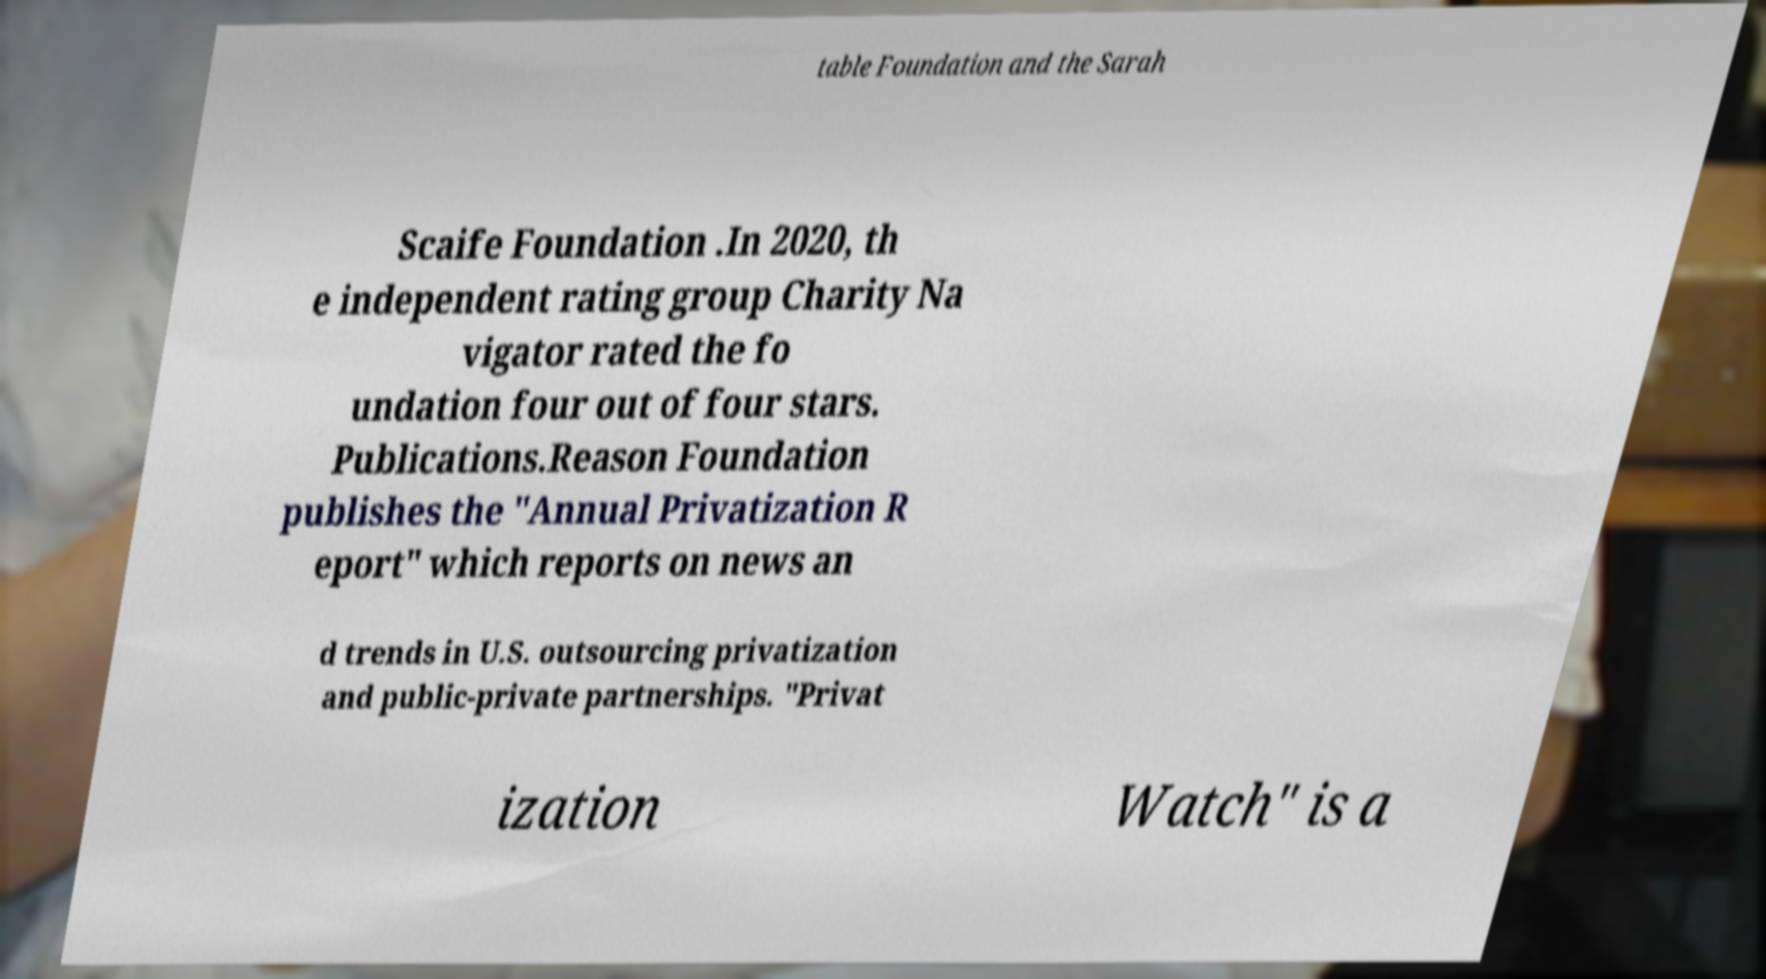For documentation purposes, I need the text within this image transcribed. Could you provide that? table Foundation and the Sarah Scaife Foundation .In 2020, th e independent rating group Charity Na vigator rated the fo undation four out of four stars. Publications.Reason Foundation publishes the "Annual Privatization R eport" which reports on news an d trends in U.S. outsourcing privatization and public-private partnerships. "Privat ization Watch" is a 